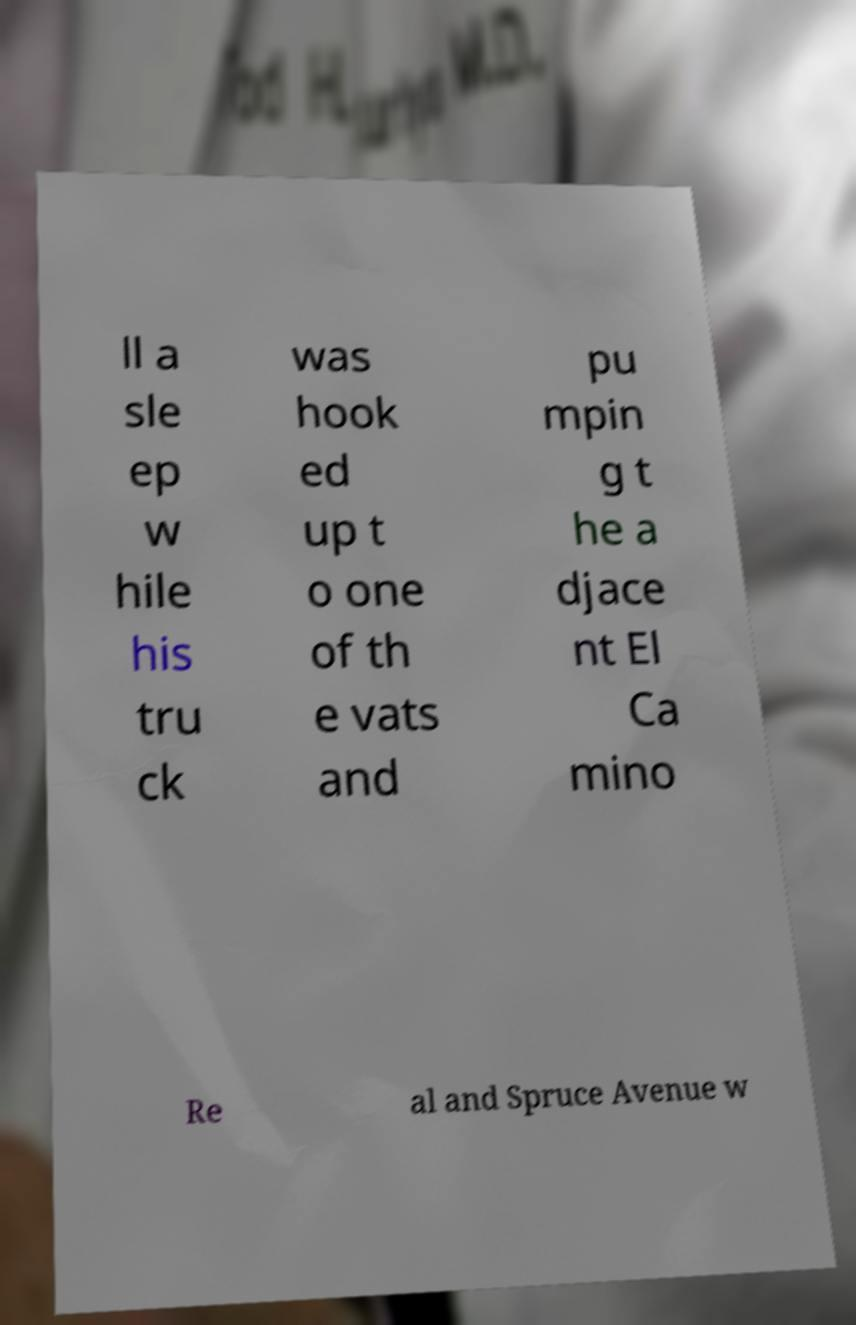Can you accurately transcribe the text from the provided image for me? ll a sle ep w hile his tru ck was hook ed up t o one of th e vats and pu mpin g t he a djace nt El Ca mino Re al and Spruce Avenue w 